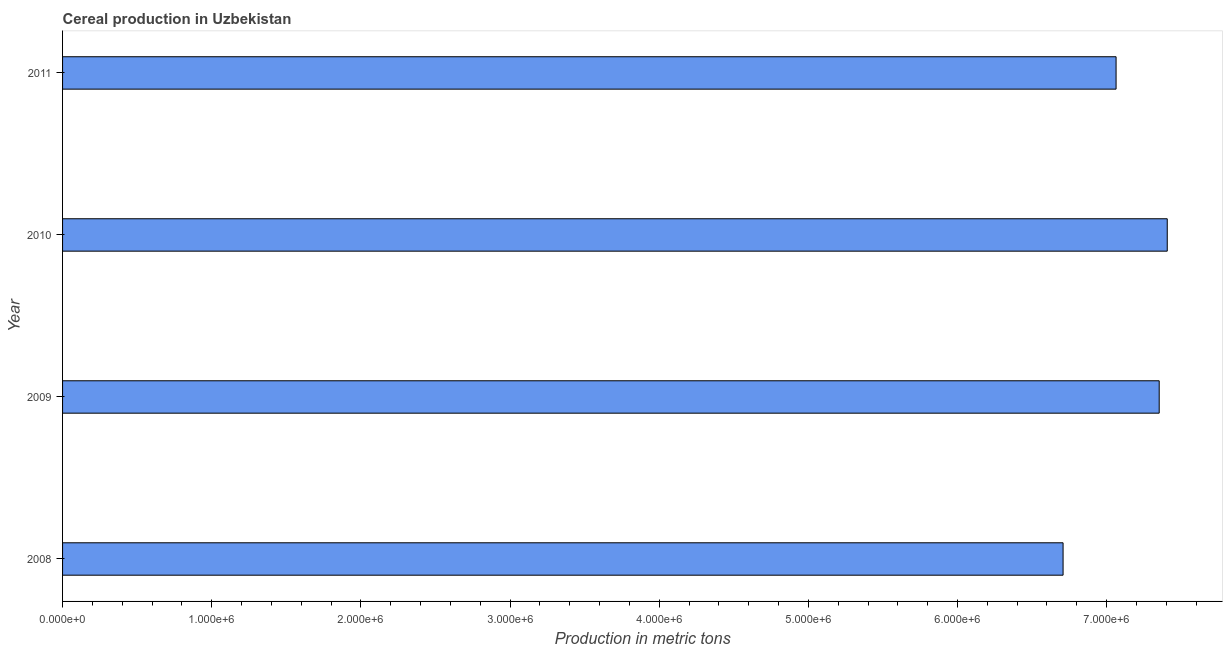Does the graph contain any zero values?
Your response must be concise. No. Does the graph contain grids?
Ensure brevity in your answer.  No. What is the title of the graph?
Offer a terse response. Cereal production in Uzbekistan. What is the label or title of the X-axis?
Provide a succinct answer. Production in metric tons. What is the cereal production in 2009?
Your response must be concise. 7.35e+06. Across all years, what is the maximum cereal production?
Provide a succinct answer. 7.41e+06. Across all years, what is the minimum cereal production?
Provide a succinct answer. 6.71e+06. What is the sum of the cereal production?
Make the answer very short. 2.85e+07. What is the difference between the cereal production in 2009 and 2011?
Your answer should be compact. 2.89e+05. What is the average cereal production per year?
Offer a very short reply. 7.13e+06. What is the median cereal production?
Your response must be concise. 7.21e+06. What is the ratio of the cereal production in 2008 to that in 2009?
Your answer should be very brief. 0.91. Is the difference between the cereal production in 2010 and 2011 greater than the difference between any two years?
Your answer should be very brief. No. What is the difference between the highest and the second highest cereal production?
Provide a short and direct response. 5.40e+04. What is the difference between the highest and the lowest cereal production?
Provide a short and direct response. 6.98e+05. In how many years, is the cereal production greater than the average cereal production taken over all years?
Keep it short and to the point. 2. Are all the bars in the graph horizontal?
Make the answer very short. Yes. What is the difference between two consecutive major ticks on the X-axis?
Make the answer very short. 1.00e+06. What is the Production in metric tons of 2008?
Offer a terse response. 6.71e+06. What is the Production in metric tons of 2009?
Provide a succinct answer. 7.35e+06. What is the Production in metric tons of 2010?
Keep it short and to the point. 7.41e+06. What is the Production in metric tons of 2011?
Offer a terse response. 7.06e+06. What is the difference between the Production in metric tons in 2008 and 2009?
Offer a terse response. -6.44e+05. What is the difference between the Production in metric tons in 2008 and 2010?
Your answer should be very brief. -6.98e+05. What is the difference between the Production in metric tons in 2008 and 2011?
Offer a very short reply. -3.55e+05. What is the difference between the Production in metric tons in 2009 and 2010?
Provide a short and direct response. -5.40e+04. What is the difference between the Production in metric tons in 2009 and 2011?
Keep it short and to the point. 2.89e+05. What is the difference between the Production in metric tons in 2010 and 2011?
Your answer should be compact. 3.43e+05. What is the ratio of the Production in metric tons in 2008 to that in 2009?
Provide a succinct answer. 0.91. What is the ratio of the Production in metric tons in 2008 to that in 2010?
Your answer should be very brief. 0.91. What is the ratio of the Production in metric tons in 2009 to that in 2010?
Keep it short and to the point. 0.99. What is the ratio of the Production in metric tons in 2009 to that in 2011?
Make the answer very short. 1.04. What is the ratio of the Production in metric tons in 2010 to that in 2011?
Your response must be concise. 1.05. 